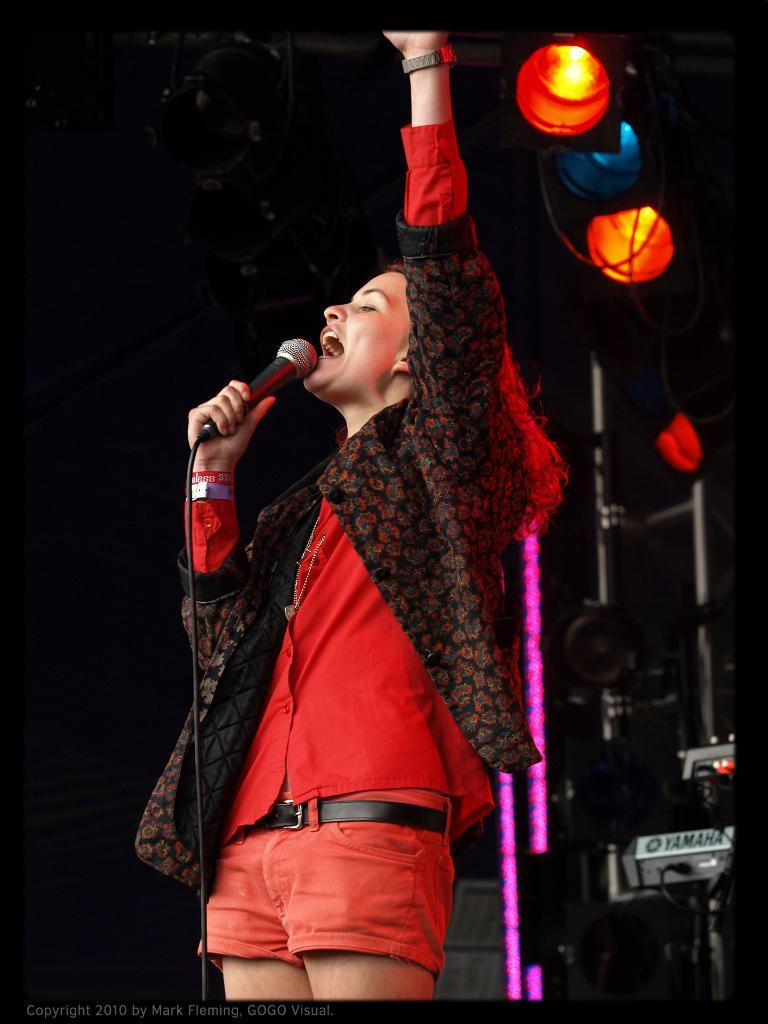Who is the main subject in the image? There is a woman in the image. What is the woman doing in the image? The woman is standing and appears to be singing. What is the woman holding in the image? The woman is holding a mic in the image. What can be seen in the background of the image? There is stage lighting visible in the background, along with other objects. What flavor of linen can be seen draped over the woman's shoulders in the image? There is no linen draped over the woman's shoulders in the image, and therefore no flavor can be associated with it. 